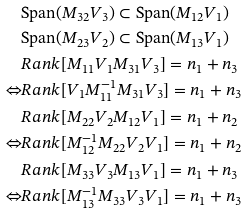<formula> <loc_0><loc_0><loc_500><loc_500>& \text {Span} ( M _ { 3 2 } V _ { 3 } ) \subset \text {Span} ( M _ { 1 2 } V _ { 1 } ) \\ & \text {Span} ( M _ { 2 3 } V _ { 2 } ) \subset \text {Span} ( M _ { 1 3 } V _ { 1 } ) \\ & R a n k [ M _ { 1 1 } V _ { 1 } M _ { 3 1 } V _ { 3 } ] = n _ { 1 } + n _ { 3 } \\ \Leftrightarrow & R a n k [ V _ { 1 } M _ { 1 1 } ^ { - 1 } M _ { 3 1 } V _ { 3 } ] = n _ { 1 } + n _ { 3 } \\ & R a n k [ M _ { 2 2 } V _ { 2 } M _ { 1 2 } V _ { 1 } ] = n _ { 1 } + n _ { 2 } \\ \Leftrightarrow & R a n k [ M _ { 1 2 } ^ { - 1 } M _ { 2 2 } V _ { 2 } V _ { 1 } ] = n _ { 1 } + n _ { 2 } \\ & R a n k [ M _ { 3 3 } V _ { 3 } M _ { 1 3 } V _ { 1 } ] = n _ { 1 } + n _ { 3 } \\ \Leftrightarrow & R a n k [ M _ { 1 3 } ^ { - 1 } M _ { 3 3 } V _ { 3 } V _ { 1 } ] = n _ { 1 } + n _ { 3 }</formula> 